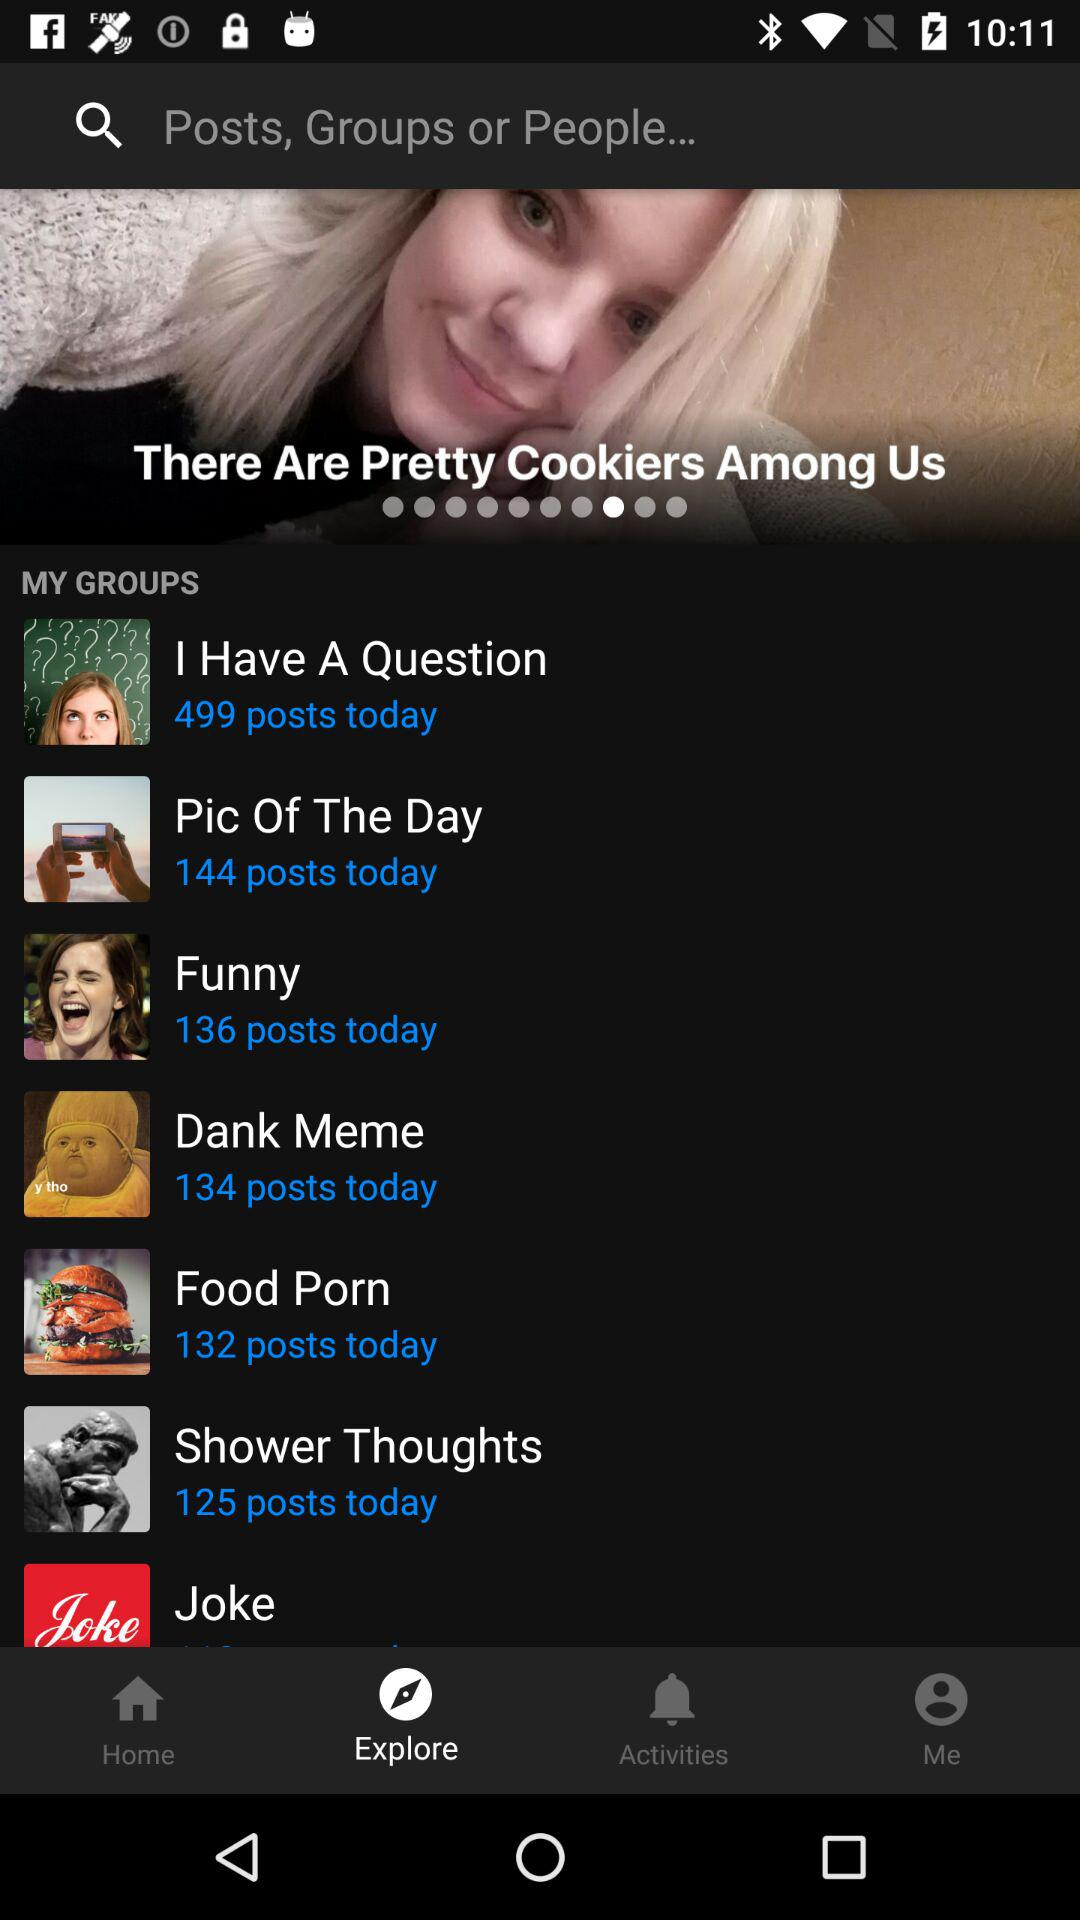How many posts are there on the 'Funny' group today?
Answer the question using a single word or phrase. 136 